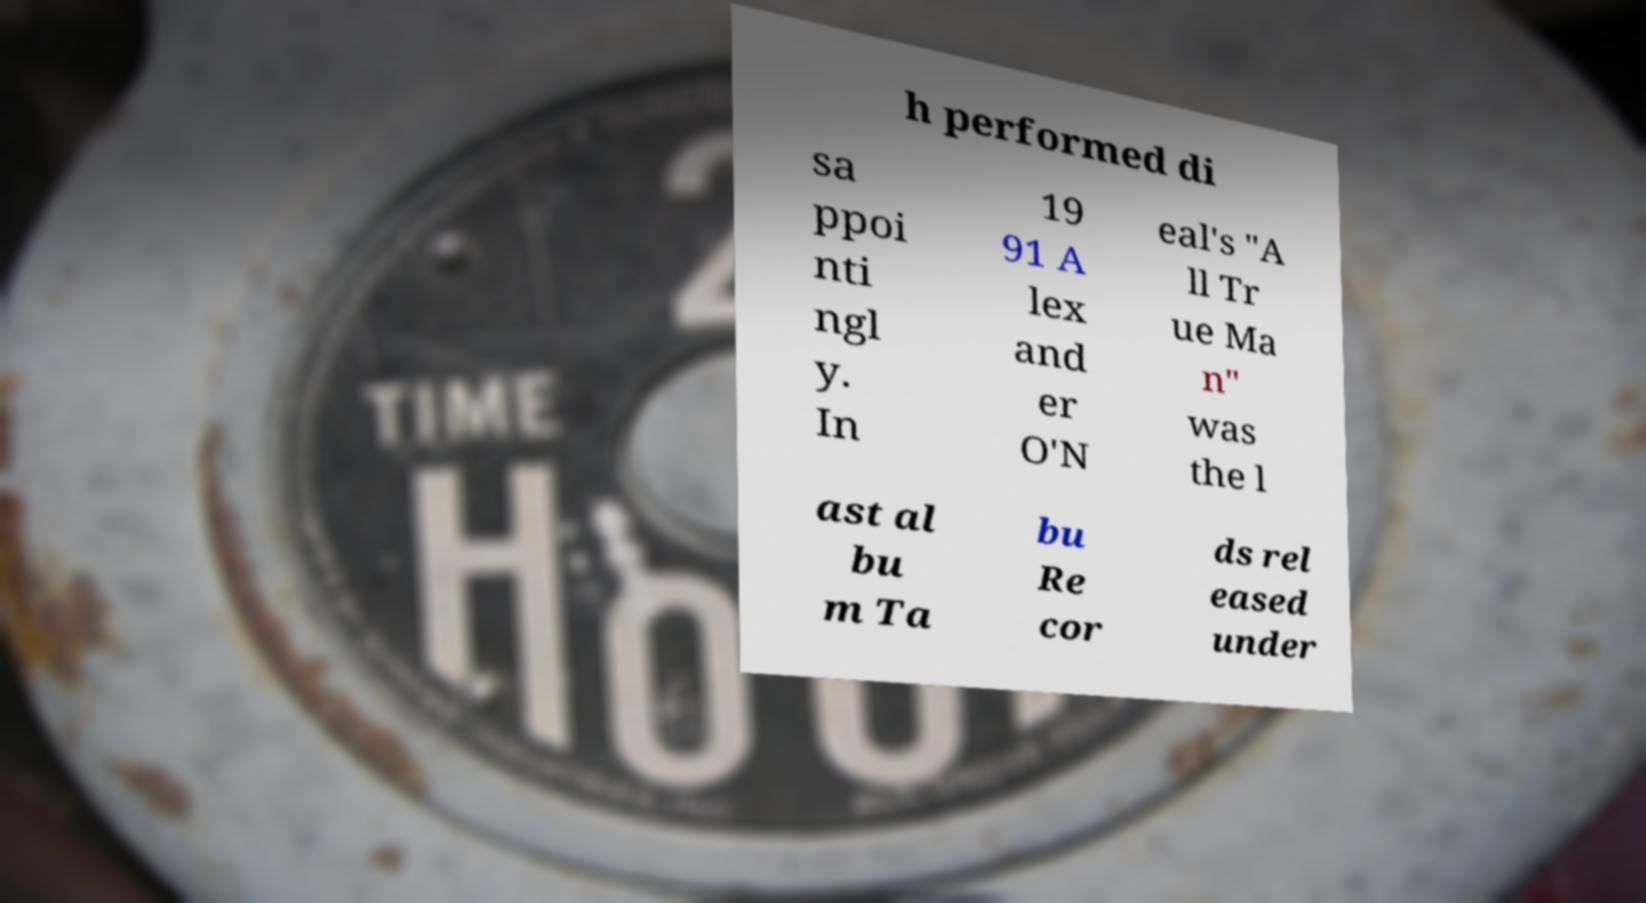Could you assist in decoding the text presented in this image and type it out clearly? h performed di sa ppoi nti ngl y. In 19 91 A lex and er O'N eal's "A ll Tr ue Ma n" was the l ast al bu m Ta bu Re cor ds rel eased under 